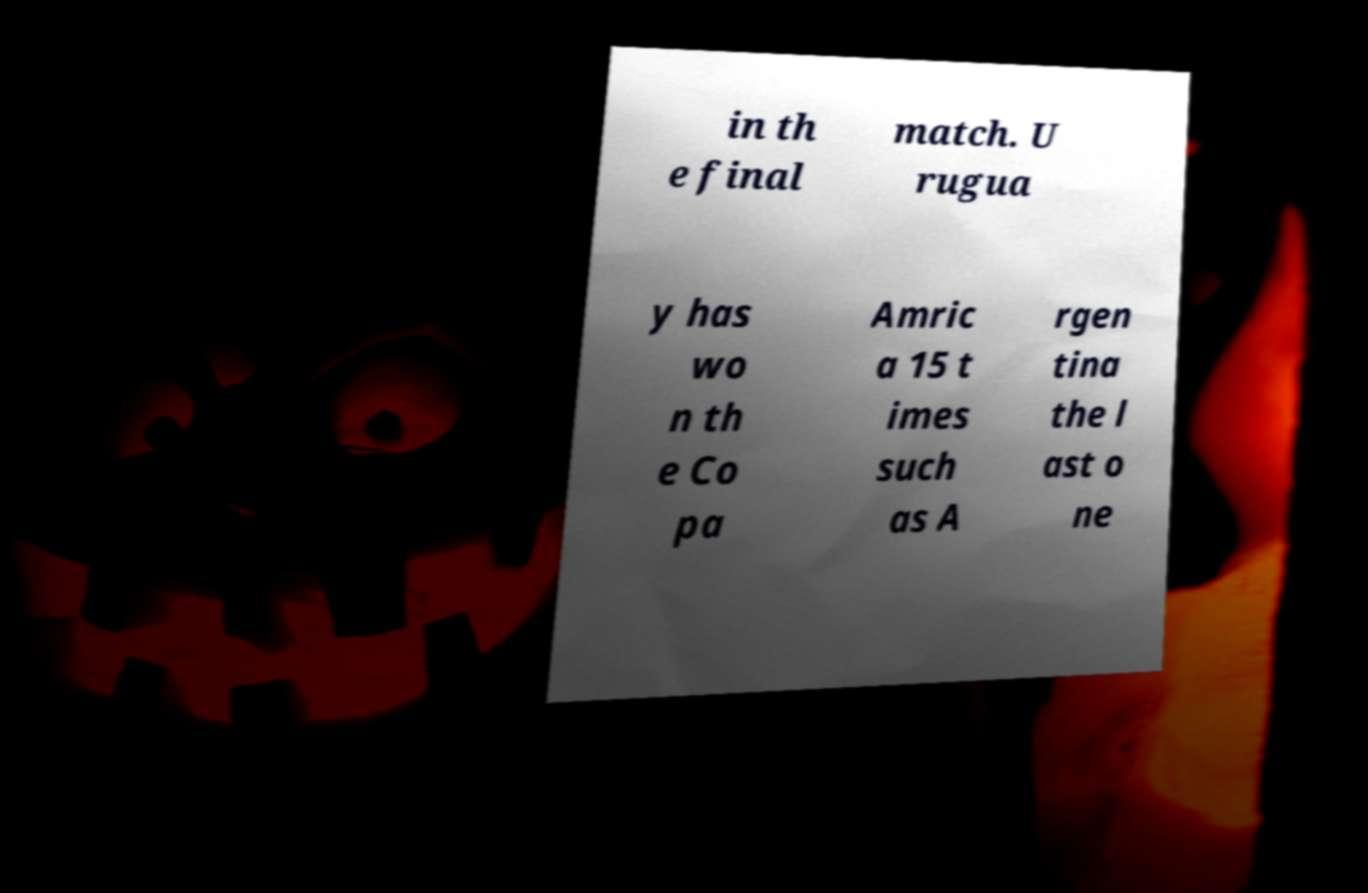Please read and relay the text visible in this image. What does it say? in th e final match. U rugua y has wo n th e Co pa Amric a 15 t imes such as A rgen tina the l ast o ne 